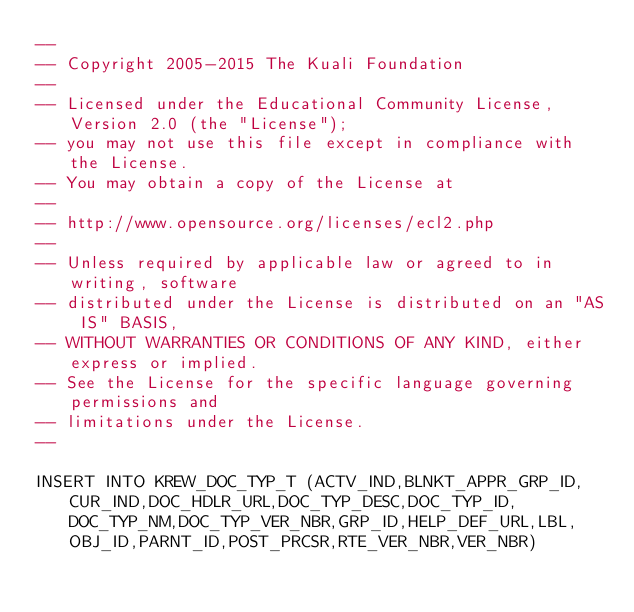Convert code to text. <code><loc_0><loc_0><loc_500><loc_500><_SQL_>--
-- Copyright 2005-2015 The Kuali Foundation
--
-- Licensed under the Educational Community License, Version 2.0 (the "License");
-- you may not use this file except in compliance with the License.
-- You may obtain a copy of the License at
--
-- http://www.opensource.org/licenses/ecl2.php
--
-- Unless required by applicable law or agreed to in writing, software
-- distributed under the License is distributed on an "AS IS" BASIS,
-- WITHOUT WARRANTIES OR CONDITIONS OF ANY KIND, either express or implied.
-- See the License for the specific language governing permissions and
-- limitations under the License.
--

INSERT INTO KREW_DOC_TYP_T (ACTV_IND,BLNKT_APPR_GRP_ID,CUR_IND,DOC_HDLR_URL,DOC_TYP_DESC,DOC_TYP_ID,DOC_TYP_NM,DOC_TYP_VER_NBR,GRP_ID,HELP_DEF_URL,LBL,OBJ_ID,PARNT_ID,POST_PRCSR,RTE_VER_NBR,VER_NBR)</code> 